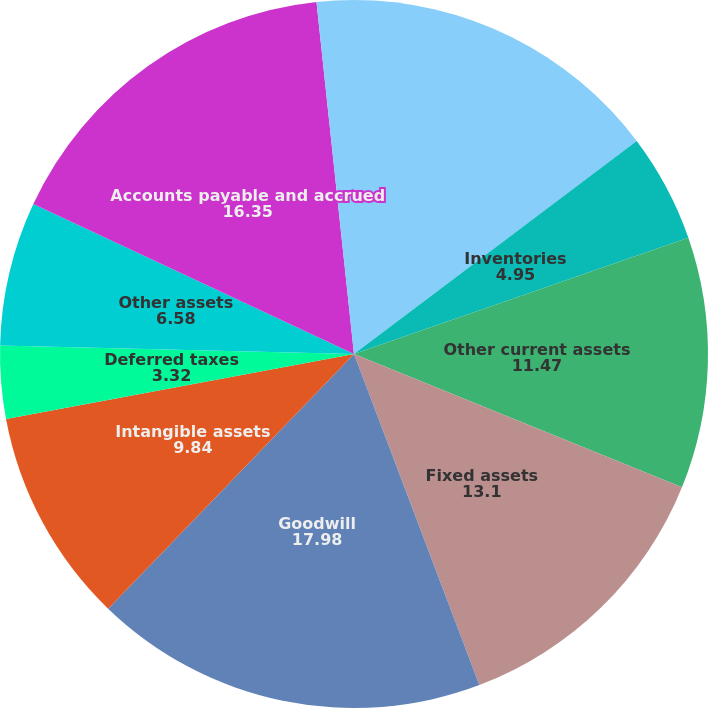Convert chart. <chart><loc_0><loc_0><loc_500><loc_500><pie_chart><fcel>Receivables<fcel>Inventories<fcel>Other current assets<fcel>Fixed assets<fcel>Goodwill<fcel>Intangible assets<fcel>Deferred taxes<fcel>Other assets<fcel>Accounts payable and accrued<fcel>Liability for taxes on income<nl><fcel>14.72%<fcel>4.95%<fcel>11.47%<fcel>13.1%<fcel>17.98%<fcel>9.84%<fcel>3.32%<fcel>6.58%<fcel>16.35%<fcel>1.69%<nl></chart> 